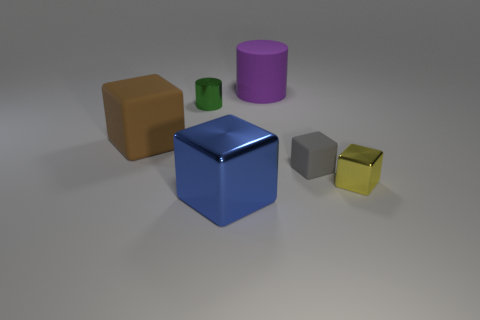What number of large matte objects are there?
Provide a short and direct response. 2. What number of cubes are left of the yellow shiny cube and right of the brown thing?
Provide a succinct answer. 2. What is the material of the big brown thing?
Your answer should be very brief. Rubber. Are there any large gray cylinders?
Make the answer very short. No. There is a small metal thing that is to the right of the big matte cylinder; what color is it?
Provide a succinct answer. Yellow. There is a object behind the tiny metal thing that is on the left side of the tiny metal cube; what number of green metallic objects are on the left side of it?
Provide a short and direct response. 1. There is a large object that is behind the small yellow object and in front of the large purple rubber object; what is it made of?
Offer a very short reply. Rubber. Is the green object made of the same material as the big cube to the left of the green metallic cylinder?
Your response must be concise. No. Is the number of brown objects in front of the tiny gray rubber block greater than the number of shiny cylinders that are in front of the large blue metallic object?
Offer a very short reply. No. The blue object is what shape?
Offer a very short reply. Cube. 